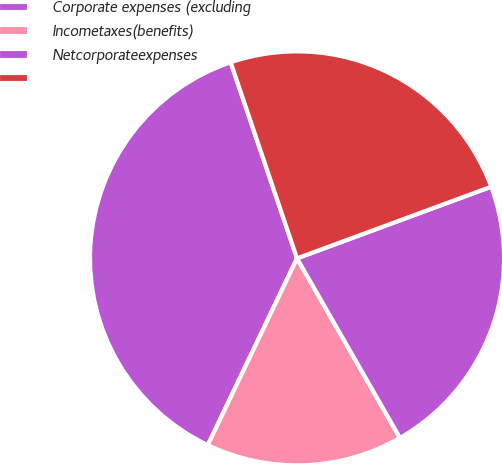<chart> <loc_0><loc_0><loc_500><loc_500><pie_chart><fcel>Corporate expenses (excluding<fcel>Incometaxes(benefits)<fcel>Netcorporateexpenses<fcel>Unnamed: 3<nl><fcel>37.71%<fcel>15.38%<fcel>22.34%<fcel>24.57%<nl></chart> 